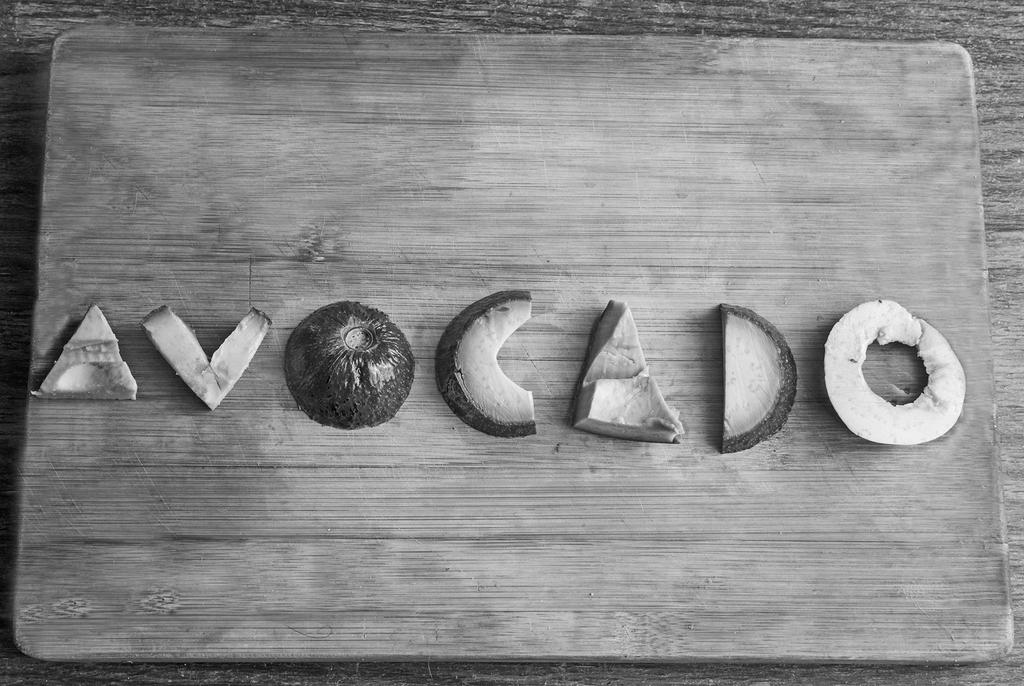What type of food can be seen in the image? There are fruit pieces in the image. What is the surface on which the fruit pieces are placed? The fruit pieces are placed on a wooden surface. How many cents are visible on the wooden surface in the image? There are no cents present in the image; it only features fruit pieces on a wooden surface. 